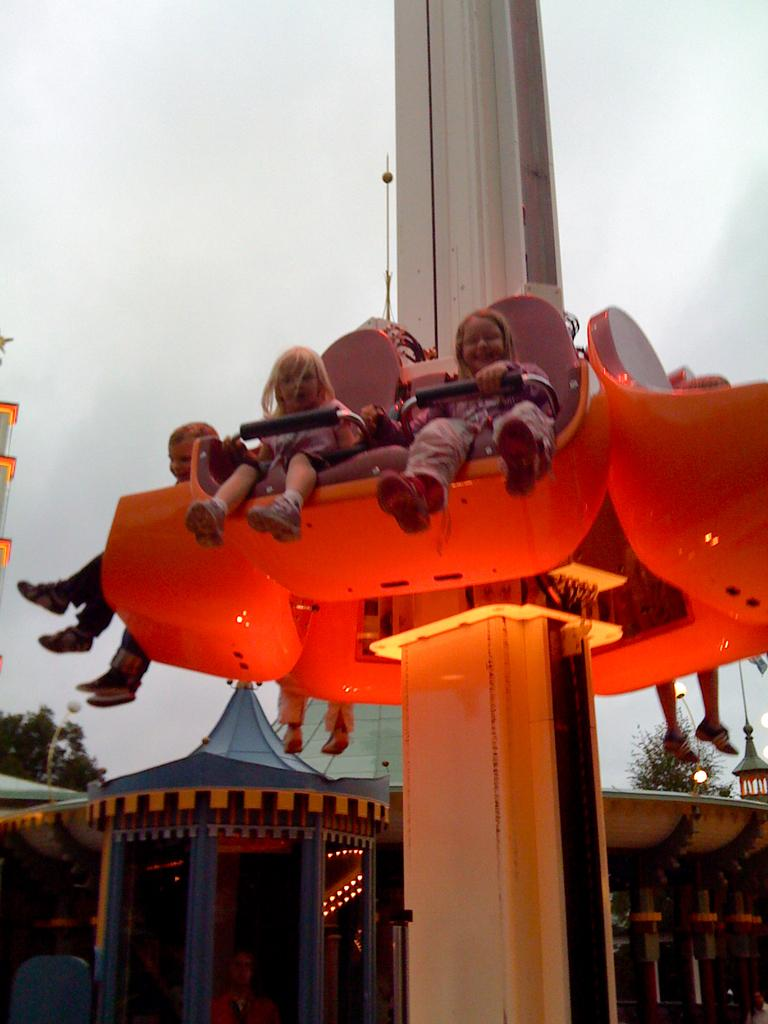What are the persons in the image doing? The persons in the image are sitting in an amusement ride. What type of setting is depicted in the image? The scene appears to be in a circus setting. What can be seen at the top of the image? The sky is visible at the top of the image. What type of apparel are the persons wearing in the image? The image does not provide enough detail to determine the specific type of apparel the persons are wearing. 